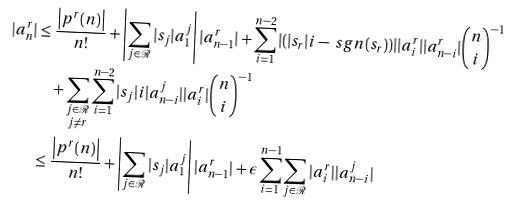Convert formula to latex. <formula><loc_0><loc_0><loc_500><loc_500>| a _ { n } ^ { r } | & \leq \frac { \left | p ^ { r } ( n ) \right | } { n ! } + \left | \sum _ { j \in \mathcal { R } } | s _ { j } | a _ { 1 } ^ { j } \right | | a ^ { r } _ { n - 1 } | + \sum _ { i = 1 } ^ { n - 2 } | ( | s _ { r } | i - \ s g n ( s _ { r } ) ) | | a ^ { r } _ { i } | | a ^ { r } _ { n - i } | \binom { n } { i } ^ { - 1 } \\ & \quad + \sum _ { \substack { j \in \mathcal { R } \\ j \neq r } } \sum _ { i = 1 } ^ { n - 2 } | s _ { j } | i | a ^ { j } _ { n - i } | | a ^ { r } _ { i } | \binom { n } { i } ^ { - 1 } \\ & \leq \frac { \left | p ^ { r } ( n ) \right | } { n ! } + \left | \sum _ { j \in \mathcal { R } } | s _ { j } | a _ { 1 } ^ { j } \right | | a ^ { r } _ { n - 1 } | + \epsilon \sum _ { i = 1 } ^ { n - 1 } \sum _ { j \in \mathcal { R } } | a ^ { r } _ { i } | | a ^ { j } _ { n - i } |</formula> 